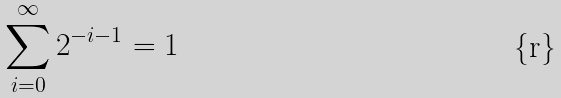<formula> <loc_0><loc_0><loc_500><loc_500>\sum _ { i = 0 } ^ { \infty } 2 ^ { - i - 1 } = 1</formula> 